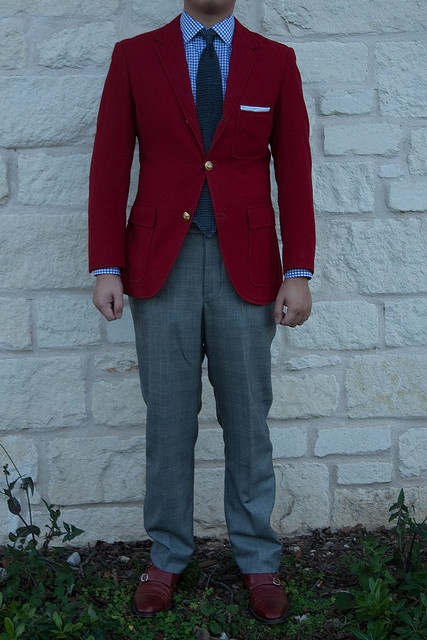Describe the objects in this image and their specific colors. I can see people in darkgray, maroon, black, blue, and darkblue tones and tie in darkgray, black, navy, darkblue, and blue tones in this image. 